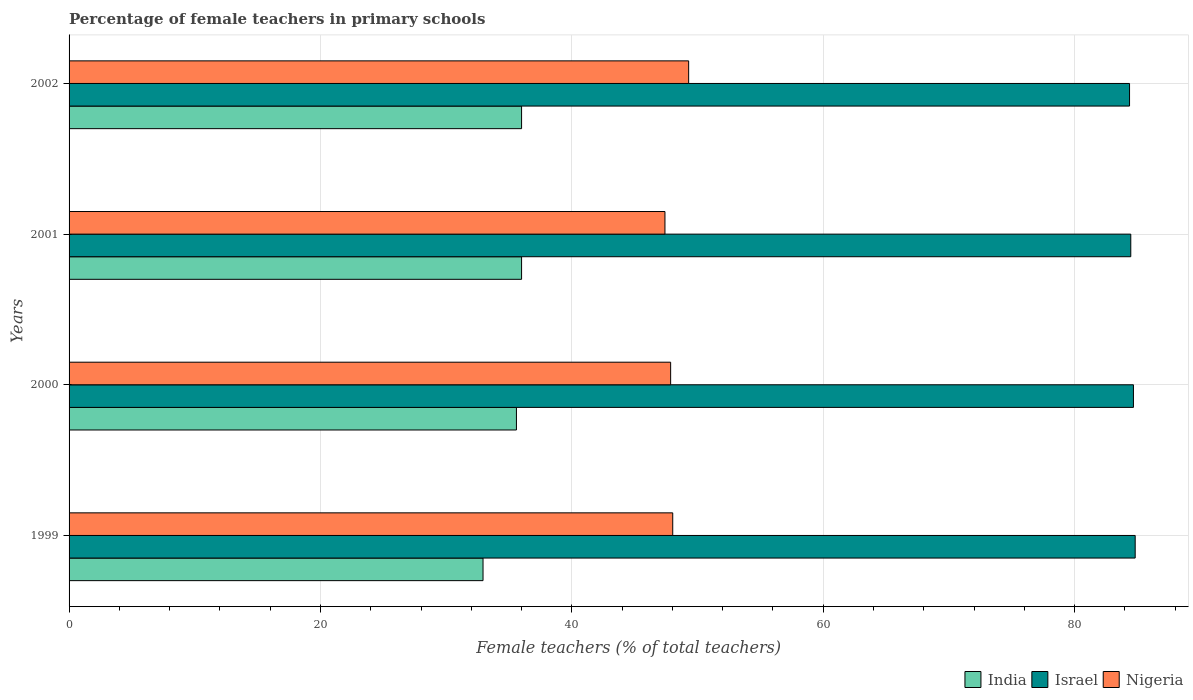Are the number of bars per tick equal to the number of legend labels?
Offer a very short reply. Yes. How many bars are there on the 4th tick from the top?
Provide a succinct answer. 3. What is the percentage of female teachers in Nigeria in 1999?
Ensure brevity in your answer.  48.02. Across all years, what is the maximum percentage of female teachers in Israel?
Your response must be concise. 84.82. Across all years, what is the minimum percentage of female teachers in India?
Offer a terse response. 32.93. In which year was the percentage of female teachers in Nigeria maximum?
Give a very brief answer. 2002. In which year was the percentage of female teachers in Nigeria minimum?
Offer a terse response. 2001. What is the total percentage of female teachers in India in the graph?
Keep it short and to the point. 140.52. What is the difference between the percentage of female teachers in Nigeria in 2000 and that in 2001?
Your answer should be very brief. 0.45. What is the difference between the percentage of female teachers in Israel in 2000 and the percentage of female teachers in Nigeria in 2001?
Your answer should be very brief. 37.27. What is the average percentage of female teachers in Nigeria per year?
Make the answer very short. 48.14. In the year 2001, what is the difference between the percentage of female teachers in India and percentage of female teachers in Israel?
Provide a succinct answer. -48.47. What is the ratio of the percentage of female teachers in India in 1999 to that in 2000?
Provide a succinct answer. 0.93. What is the difference between the highest and the second highest percentage of female teachers in Israel?
Make the answer very short. 0.14. What is the difference between the highest and the lowest percentage of female teachers in India?
Offer a very short reply. 3.07. In how many years, is the percentage of female teachers in India greater than the average percentage of female teachers in India taken over all years?
Make the answer very short. 3. Is it the case that in every year, the sum of the percentage of female teachers in Israel and percentage of female teachers in India is greater than the percentage of female teachers in Nigeria?
Ensure brevity in your answer.  Yes. How many years are there in the graph?
Keep it short and to the point. 4. Are the values on the major ticks of X-axis written in scientific E-notation?
Provide a succinct answer. No. Where does the legend appear in the graph?
Ensure brevity in your answer.  Bottom right. How are the legend labels stacked?
Ensure brevity in your answer.  Horizontal. What is the title of the graph?
Give a very brief answer. Percentage of female teachers in primary schools. Does "Mali" appear as one of the legend labels in the graph?
Make the answer very short. No. What is the label or title of the X-axis?
Offer a terse response. Female teachers (% of total teachers). What is the Female teachers (% of total teachers) in India in 1999?
Your answer should be very brief. 32.93. What is the Female teachers (% of total teachers) of Israel in 1999?
Provide a short and direct response. 84.82. What is the Female teachers (% of total teachers) of Nigeria in 1999?
Provide a succinct answer. 48.02. What is the Female teachers (% of total teachers) of India in 2000?
Your answer should be compact. 35.59. What is the Female teachers (% of total teachers) of Israel in 2000?
Keep it short and to the point. 84.68. What is the Female teachers (% of total teachers) of Nigeria in 2000?
Give a very brief answer. 47.86. What is the Female teachers (% of total teachers) of India in 2001?
Offer a very short reply. 36. What is the Female teachers (% of total teachers) in Israel in 2001?
Keep it short and to the point. 84.47. What is the Female teachers (% of total teachers) in Nigeria in 2001?
Offer a terse response. 47.41. What is the Female teachers (% of total teachers) of India in 2002?
Keep it short and to the point. 36. What is the Female teachers (% of total teachers) of Israel in 2002?
Keep it short and to the point. 84.37. What is the Female teachers (% of total teachers) of Nigeria in 2002?
Ensure brevity in your answer.  49.29. Across all years, what is the maximum Female teachers (% of total teachers) in India?
Ensure brevity in your answer.  36. Across all years, what is the maximum Female teachers (% of total teachers) of Israel?
Your answer should be compact. 84.82. Across all years, what is the maximum Female teachers (% of total teachers) in Nigeria?
Keep it short and to the point. 49.29. Across all years, what is the minimum Female teachers (% of total teachers) in India?
Offer a very short reply. 32.93. Across all years, what is the minimum Female teachers (% of total teachers) in Israel?
Make the answer very short. 84.37. Across all years, what is the minimum Female teachers (% of total teachers) of Nigeria?
Your answer should be compact. 47.41. What is the total Female teachers (% of total teachers) in India in the graph?
Provide a short and direct response. 140.52. What is the total Female teachers (% of total teachers) of Israel in the graph?
Your answer should be very brief. 338.32. What is the total Female teachers (% of total teachers) of Nigeria in the graph?
Make the answer very short. 192.58. What is the difference between the Female teachers (% of total teachers) in India in 1999 and that in 2000?
Your answer should be very brief. -2.66. What is the difference between the Female teachers (% of total teachers) of Israel in 1999 and that in 2000?
Offer a very short reply. 0.14. What is the difference between the Female teachers (% of total teachers) in Nigeria in 1999 and that in 2000?
Your answer should be compact. 0.17. What is the difference between the Female teachers (% of total teachers) in India in 1999 and that in 2001?
Offer a terse response. -3.07. What is the difference between the Female teachers (% of total teachers) in Israel in 1999 and that in 2001?
Your response must be concise. 0.35. What is the difference between the Female teachers (% of total teachers) in Nigeria in 1999 and that in 2001?
Provide a succinct answer. 0.62. What is the difference between the Female teachers (% of total teachers) in India in 1999 and that in 2002?
Ensure brevity in your answer.  -3.07. What is the difference between the Female teachers (% of total teachers) of Israel in 1999 and that in 2002?
Provide a short and direct response. 0.45. What is the difference between the Female teachers (% of total teachers) in Nigeria in 1999 and that in 2002?
Your answer should be compact. -1.27. What is the difference between the Female teachers (% of total teachers) in India in 2000 and that in 2001?
Give a very brief answer. -0.41. What is the difference between the Female teachers (% of total teachers) of Israel in 2000 and that in 2001?
Give a very brief answer. 0.21. What is the difference between the Female teachers (% of total teachers) of Nigeria in 2000 and that in 2001?
Provide a short and direct response. 0.45. What is the difference between the Female teachers (% of total teachers) of India in 2000 and that in 2002?
Provide a succinct answer. -0.41. What is the difference between the Female teachers (% of total teachers) in Israel in 2000 and that in 2002?
Make the answer very short. 0.31. What is the difference between the Female teachers (% of total teachers) of Nigeria in 2000 and that in 2002?
Ensure brevity in your answer.  -1.43. What is the difference between the Female teachers (% of total teachers) of India in 2001 and that in 2002?
Your answer should be very brief. 0. What is the difference between the Female teachers (% of total teachers) of Israel in 2001 and that in 2002?
Make the answer very short. 0.1. What is the difference between the Female teachers (% of total teachers) in Nigeria in 2001 and that in 2002?
Provide a short and direct response. -1.89. What is the difference between the Female teachers (% of total teachers) of India in 1999 and the Female teachers (% of total teachers) of Israel in 2000?
Make the answer very short. -51.74. What is the difference between the Female teachers (% of total teachers) of India in 1999 and the Female teachers (% of total teachers) of Nigeria in 2000?
Give a very brief answer. -14.93. What is the difference between the Female teachers (% of total teachers) in Israel in 1999 and the Female teachers (% of total teachers) in Nigeria in 2000?
Offer a terse response. 36.96. What is the difference between the Female teachers (% of total teachers) of India in 1999 and the Female teachers (% of total teachers) of Israel in 2001?
Provide a succinct answer. -51.53. What is the difference between the Female teachers (% of total teachers) of India in 1999 and the Female teachers (% of total teachers) of Nigeria in 2001?
Keep it short and to the point. -14.47. What is the difference between the Female teachers (% of total teachers) in Israel in 1999 and the Female teachers (% of total teachers) in Nigeria in 2001?
Your response must be concise. 37.41. What is the difference between the Female teachers (% of total teachers) in India in 1999 and the Female teachers (% of total teachers) in Israel in 2002?
Offer a very short reply. -51.43. What is the difference between the Female teachers (% of total teachers) in India in 1999 and the Female teachers (% of total teachers) in Nigeria in 2002?
Your response must be concise. -16.36. What is the difference between the Female teachers (% of total teachers) in Israel in 1999 and the Female teachers (% of total teachers) in Nigeria in 2002?
Provide a succinct answer. 35.52. What is the difference between the Female teachers (% of total teachers) of India in 2000 and the Female teachers (% of total teachers) of Israel in 2001?
Keep it short and to the point. -48.88. What is the difference between the Female teachers (% of total teachers) of India in 2000 and the Female teachers (% of total teachers) of Nigeria in 2001?
Your answer should be very brief. -11.82. What is the difference between the Female teachers (% of total teachers) of Israel in 2000 and the Female teachers (% of total teachers) of Nigeria in 2001?
Your answer should be compact. 37.27. What is the difference between the Female teachers (% of total teachers) of India in 2000 and the Female teachers (% of total teachers) of Israel in 2002?
Provide a short and direct response. -48.78. What is the difference between the Female teachers (% of total teachers) of India in 2000 and the Female teachers (% of total teachers) of Nigeria in 2002?
Offer a very short reply. -13.7. What is the difference between the Female teachers (% of total teachers) of Israel in 2000 and the Female teachers (% of total teachers) of Nigeria in 2002?
Make the answer very short. 35.38. What is the difference between the Female teachers (% of total teachers) of India in 2001 and the Female teachers (% of total teachers) of Israel in 2002?
Offer a very short reply. -48.37. What is the difference between the Female teachers (% of total teachers) in India in 2001 and the Female teachers (% of total teachers) in Nigeria in 2002?
Your response must be concise. -13.29. What is the difference between the Female teachers (% of total teachers) of Israel in 2001 and the Female teachers (% of total teachers) of Nigeria in 2002?
Give a very brief answer. 35.17. What is the average Female teachers (% of total teachers) in India per year?
Offer a very short reply. 35.13. What is the average Female teachers (% of total teachers) in Israel per year?
Ensure brevity in your answer.  84.58. What is the average Female teachers (% of total teachers) in Nigeria per year?
Offer a terse response. 48.15. In the year 1999, what is the difference between the Female teachers (% of total teachers) of India and Female teachers (% of total teachers) of Israel?
Your answer should be very brief. -51.88. In the year 1999, what is the difference between the Female teachers (% of total teachers) in India and Female teachers (% of total teachers) in Nigeria?
Offer a terse response. -15.09. In the year 1999, what is the difference between the Female teachers (% of total teachers) of Israel and Female teachers (% of total teachers) of Nigeria?
Offer a very short reply. 36.79. In the year 2000, what is the difference between the Female teachers (% of total teachers) of India and Female teachers (% of total teachers) of Israel?
Your response must be concise. -49.09. In the year 2000, what is the difference between the Female teachers (% of total teachers) in India and Female teachers (% of total teachers) in Nigeria?
Make the answer very short. -12.27. In the year 2000, what is the difference between the Female teachers (% of total teachers) in Israel and Female teachers (% of total teachers) in Nigeria?
Make the answer very short. 36.82. In the year 2001, what is the difference between the Female teachers (% of total teachers) in India and Female teachers (% of total teachers) in Israel?
Provide a short and direct response. -48.47. In the year 2001, what is the difference between the Female teachers (% of total teachers) in India and Female teachers (% of total teachers) in Nigeria?
Keep it short and to the point. -11.41. In the year 2001, what is the difference between the Female teachers (% of total teachers) of Israel and Female teachers (% of total teachers) of Nigeria?
Give a very brief answer. 37.06. In the year 2002, what is the difference between the Female teachers (% of total teachers) of India and Female teachers (% of total teachers) of Israel?
Make the answer very short. -48.37. In the year 2002, what is the difference between the Female teachers (% of total teachers) of India and Female teachers (% of total teachers) of Nigeria?
Keep it short and to the point. -13.29. In the year 2002, what is the difference between the Female teachers (% of total teachers) of Israel and Female teachers (% of total teachers) of Nigeria?
Your answer should be compact. 35.08. What is the ratio of the Female teachers (% of total teachers) in India in 1999 to that in 2000?
Keep it short and to the point. 0.93. What is the ratio of the Female teachers (% of total teachers) of India in 1999 to that in 2001?
Make the answer very short. 0.91. What is the ratio of the Female teachers (% of total teachers) in Israel in 1999 to that in 2001?
Your answer should be very brief. 1. What is the ratio of the Female teachers (% of total teachers) of Nigeria in 1999 to that in 2001?
Your response must be concise. 1.01. What is the ratio of the Female teachers (% of total teachers) in India in 1999 to that in 2002?
Your answer should be compact. 0.91. What is the ratio of the Female teachers (% of total teachers) of Israel in 1999 to that in 2002?
Your answer should be compact. 1.01. What is the ratio of the Female teachers (% of total teachers) of Nigeria in 1999 to that in 2002?
Your answer should be very brief. 0.97. What is the ratio of the Female teachers (% of total teachers) of Nigeria in 2000 to that in 2001?
Your answer should be compact. 1.01. What is the ratio of the Female teachers (% of total teachers) of Nigeria in 2000 to that in 2002?
Make the answer very short. 0.97. What is the ratio of the Female teachers (% of total teachers) in India in 2001 to that in 2002?
Ensure brevity in your answer.  1. What is the ratio of the Female teachers (% of total teachers) in Nigeria in 2001 to that in 2002?
Give a very brief answer. 0.96. What is the difference between the highest and the second highest Female teachers (% of total teachers) of India?
Keep it short and to the point. 0. What is the difference between the highest and the second highest Female teachers (% of total teachers) in Israel?
Provide a short and direct response. 0.14. What is the difference between the highest and the second highest Female teachers (% of total teachers) in Nigeria?
Offer a very short reply. 1.27. What is the difference between the highest and the lowest Female teachers (% of total teachers) in India?
Offer a very short reply. 3.07. What is the difference between the highest and the lowest Female teachers (% of total teachers) in Israel?
Offer a very short reply. 0.45. What is the difference between the highest and the lowest Female teachers (% of total teachers) in Nigeria?
Your answer should be very brief. 1.89. 